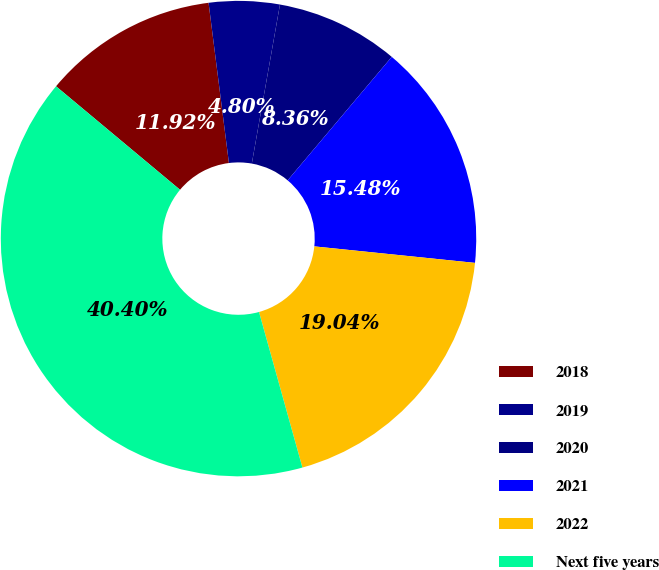Convert chart to OTSL. <chart><loc_0><loc_0><loc_500><loc_500><pie_chart><fcel>2018<fcel>2019<fcel>2020<fcel>2021<fcel>2022<fcel>Next five years<nl><fcel>11.92%<fcel>4.8%<fcel>8.36%<fcel>15.48%<fcel>19.04%<fcel>40.4%<nl></chart> 